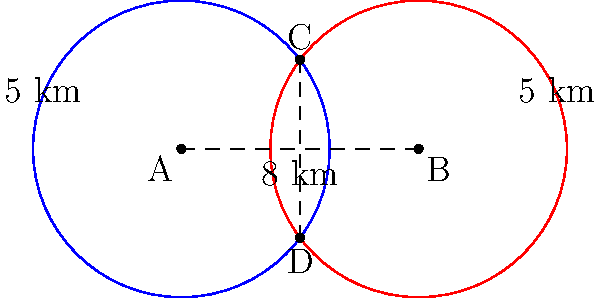Two lifeguard stations, A and B, are located 8 km apart along Myrtle Beach. Each station has a patrol range of 5 km. What is the width of the area where both stations' ranges overlap, measured perpendicular to the coastline? Round your answer to the nearest tenth of a kilometer. Let's approach this step-by-step:

1) This problem can be solved using the properties of intersecting circles. The two lifeguard stations represent the centers of two circles, each with a radius of 5 km.

2) The line connecting the centers (AB) is 8 km long, and the radii are both 5 km. This forms an isosceles triangle.

3) Let's call the intersection points C and D. The line CD represents the width of the overlapping area.

4) To find CD, we need to use the Pythagorean theorem in the right triangle formed by half of AB, half of CD, and one of the radii.

5) Let's call the half-width of CD as x. Then:

   $$5^2 = 4^2 + x^2$$

6) Solving for x:

   $$25 = 16 + x^2$$
   $$x^2 = 9$$
   $$x = 3$$

7) Since x is half of CD, the full width CD is 2x = 6 km.

Therefore, the width of the overlapping area is 6 km.
Answer: 6.0 km 